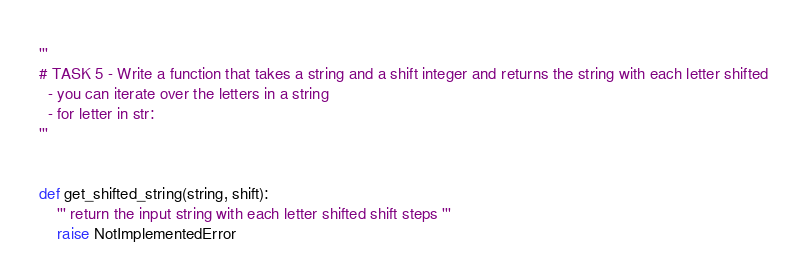<code> <loc_0><loc_0><loc_500><loc_500><_Python_>'''
# TASK 5 - Write a function that takes a string and a shift integer and returns the string with each letter shifted
  - you can iterate over the letters in a string
  - for letter in str:
'''


def get_shifted_string(string, shift):
    ''' return the input string with each letter shifted shift steps '''
    raise NotImplementedError
</code> 